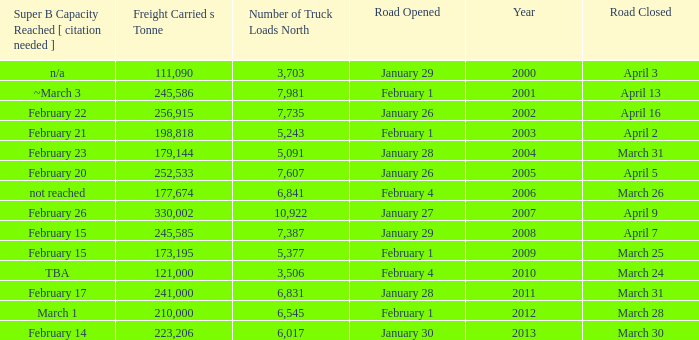What is the smallest amount of freight carried on the road that closed on March 31 and reached super B capacity on February 17 after 2011? None. 